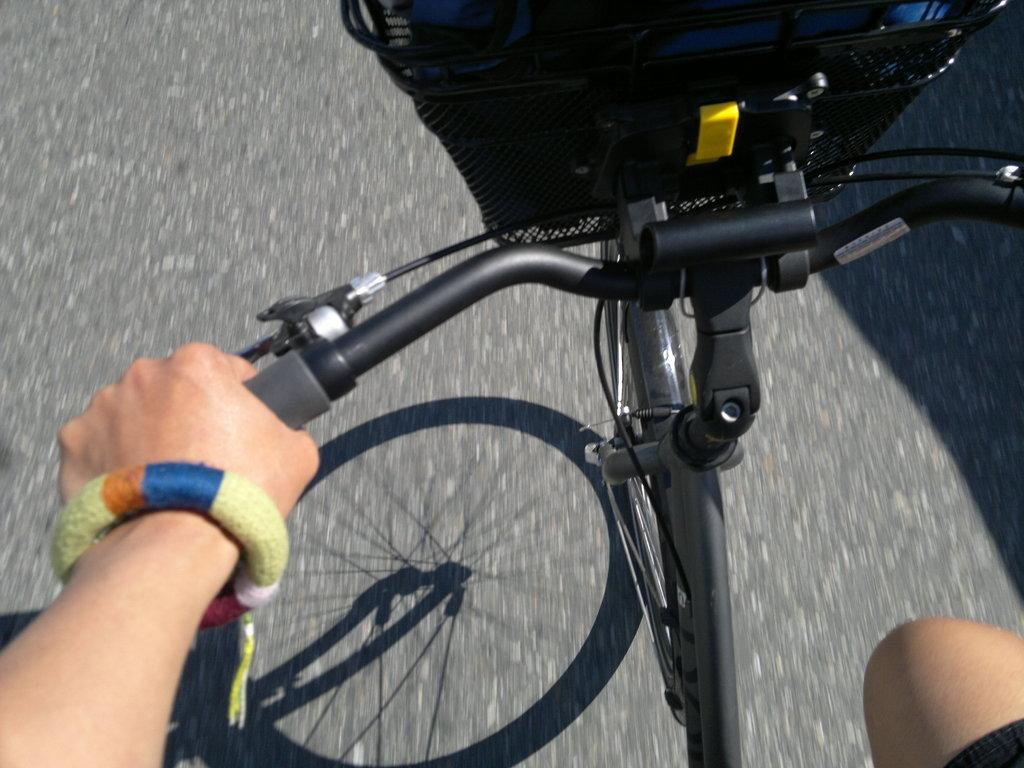What is the main subject of the image? There is a person in the image. What is the person doing in the image? The person is cycling a bicycle. Can you describe any additional features in the image? There is a basket in the top of the image. What can be seen in the background of the image? There is a road in the background of the image. What type of engine is powering the carriage in the image? There is no carriage or engine present in the image; it features a person cycling a bicycle. What is the stem used for in the image? There is no stem present in the image. 